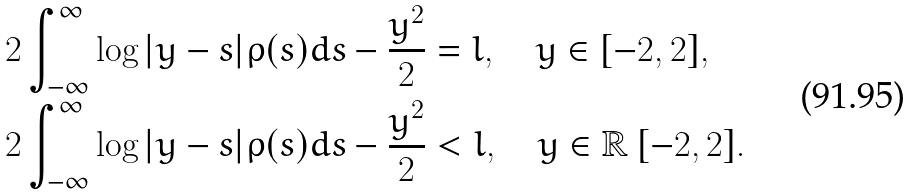<formula> <loc_0><loc_0><loc_500><loc_500>& 2 \int _ { - \infty } ^ { \infty } \log | y - s | \rho ( s ) d s - \frac { y ^ { 2 } } { 2 } = l , \quad y \in [ - 2 , 2 ] , \\ & 2 \int _ { - \infty } ^ { \infty } \log | y - s | \rho ( s ) d s - \frac { y ^ { 2 } } { 2 } < l , \quad y \in \mathbb { R } \ [ - 2 , 2 ] .</formula> 